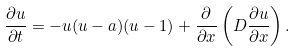Convert formula to latex. <formula><loc_0><loc_0><loc_500><loc_500>\frac { \partial u } { \partial t } = - u ( u - a ) ( u - 1 ) + \frac { \partial } { \partial x } \left ( D \frac { \partial u } { \partial x } \right ) .</formula> 